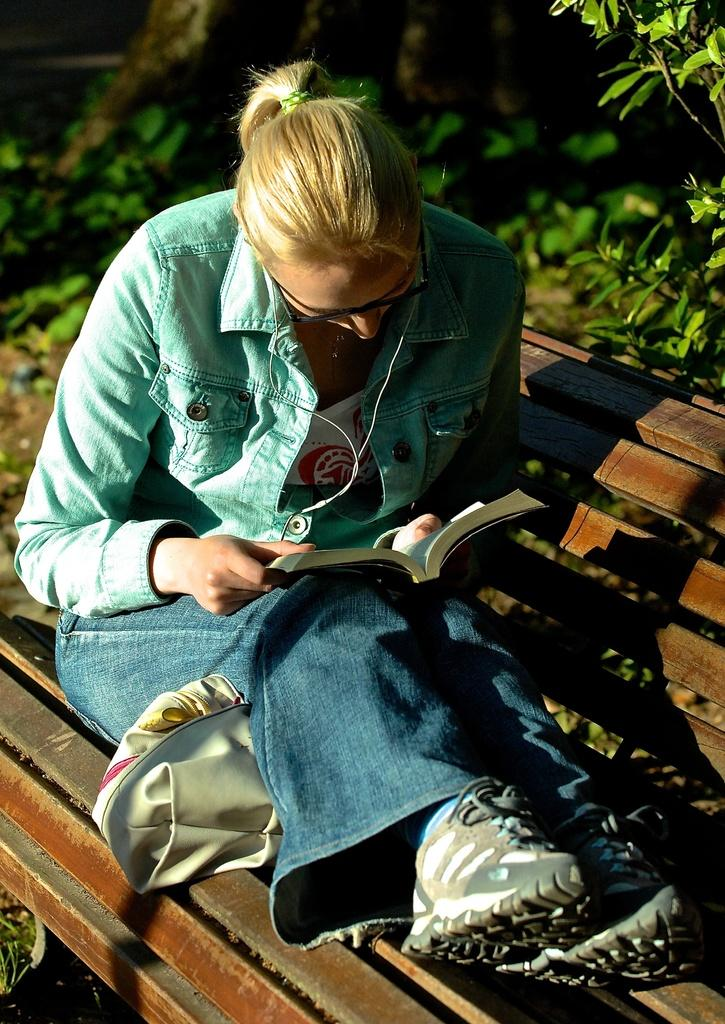Who is the main subject in the image? There is a woman in the image. What is the woman doing in the image? The woman is seated on a bench and reading a book. How is the woman holding the book? The book is held in her hands. What can be seen in the background of the image? There are trees visible in the image. What item is present on the bench under the woman's legs? There is a handbag on the bench under the woman's legs. What flavor of toothbrush is the woman using in the image? There is no toothbrush present in the image, and therefore no flavor can be determined. 